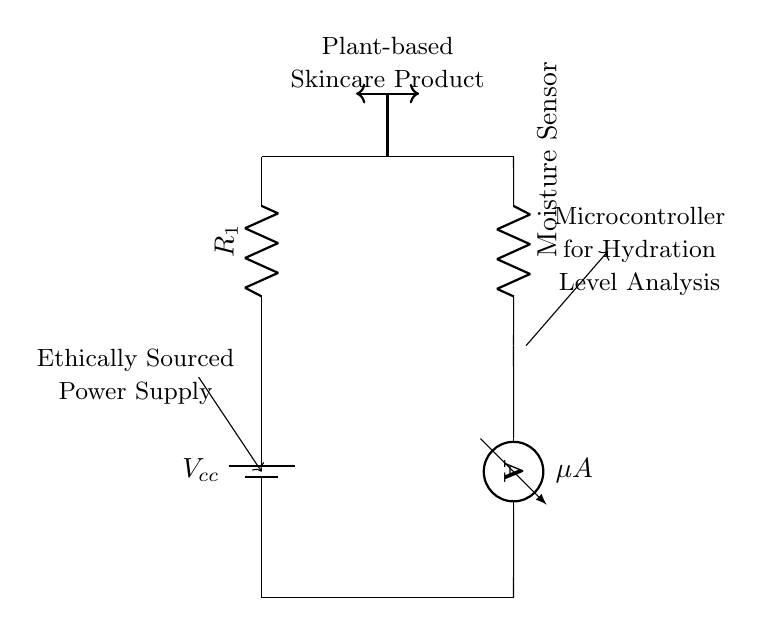What is the type of power supply used in this circuit? The circuit specifies an ethically sourced power supply, indicated by the labeling on the left side of the circuit diagram. This highlights the importance of ethical considerations in sourcing power for the device.
Answer: Ethically Sourced Power Supply What does the moisture sensor measure? The moisture sensor in this circuit is designed to measure hydration levels within the plant-based skincare product, as indicated by its position following the resistor in the circuit.
Answer: Hydration Levels What current measurement is indicated in this circuit? The circuit diagram includes an ammeter component, labeled with the symbol ‘mu A,’ which signifies the measurement of micro-amperes in the system, representing the current flowing through the moisture sensor.
Answer: Micro Amperes What role does the microcontroller play in this circuit? The microcontroller is responsible for analyzing the hydration levels indicated by the moisture sensor; its position in the diagram follows the sensor, showing its connection to the data being measured.
Answer: Hydration Level Analysis What component directly connects to the moisture sensor? The component that directly connects to the moisture sensor is a resistor, identified as R1 in the circuit diagram. It is positioned before the sensor, indicating it facilitates the function of the sensor by controlling the voltage or current.
Answer: Resistor How many main components are seen in this circuit? The circuit features four key components: a power supply, a resistor, a moisture sensor, and an ammeter, all of which are necessary for the measurement and monitoring functionality.
Answer: Four 